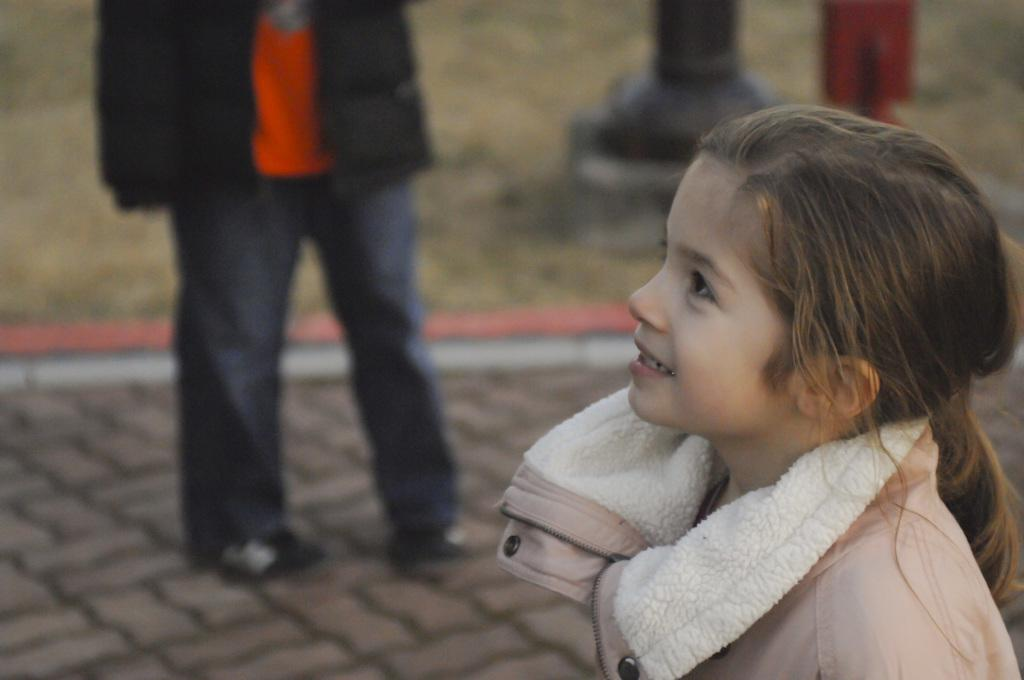What is the person in the foreground wearing in the image? The person in the foreground is wearing a peach color coat in the image. Can you describe the person in the background? The person in the background is visible but blurred. What type of authority does the person in the image have over the sugar in the brain? There is no mention of sugar or the brain in the image, so this question cannot be answered. 